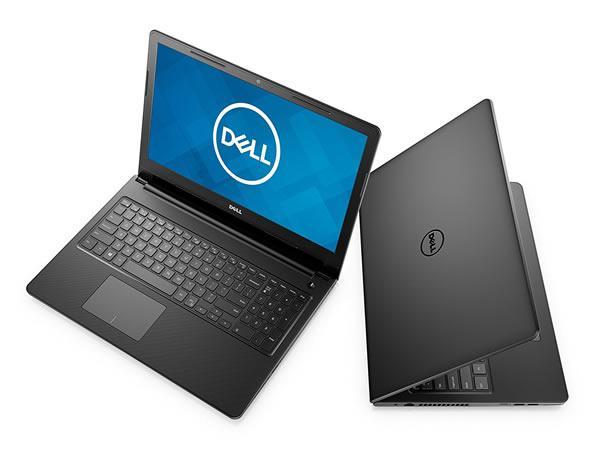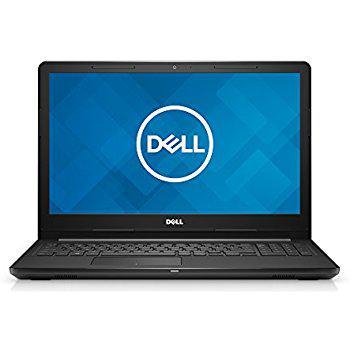The first image is the image on the left, the second image is the image on the right. For the images shown, is this caption "All the laptops are fully open with visible screens." true? Answer yes or no. No. The first image is the image on the left, the second image is the image on the right. For the images shown, is this caption "The back side of a laptop is visible in one of the images." true? Answer yes or no. Yes. 